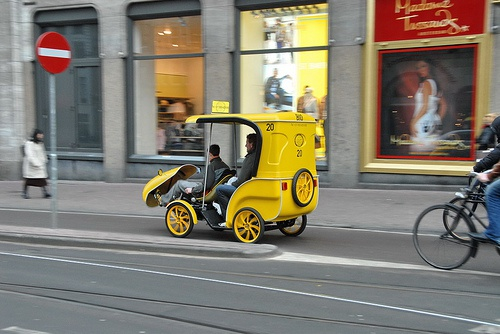Describe the objects in this image and their specific colors. I can see bicycle in darkgray, gray, and black tones, people in darkgray, lightgray, black, and gray tones, people in darkgray, black, and gray tones, people in darkgray, black, gray, blue, and lightgray tones, and bicycle in darkgray, black, and gray tones in this image. 